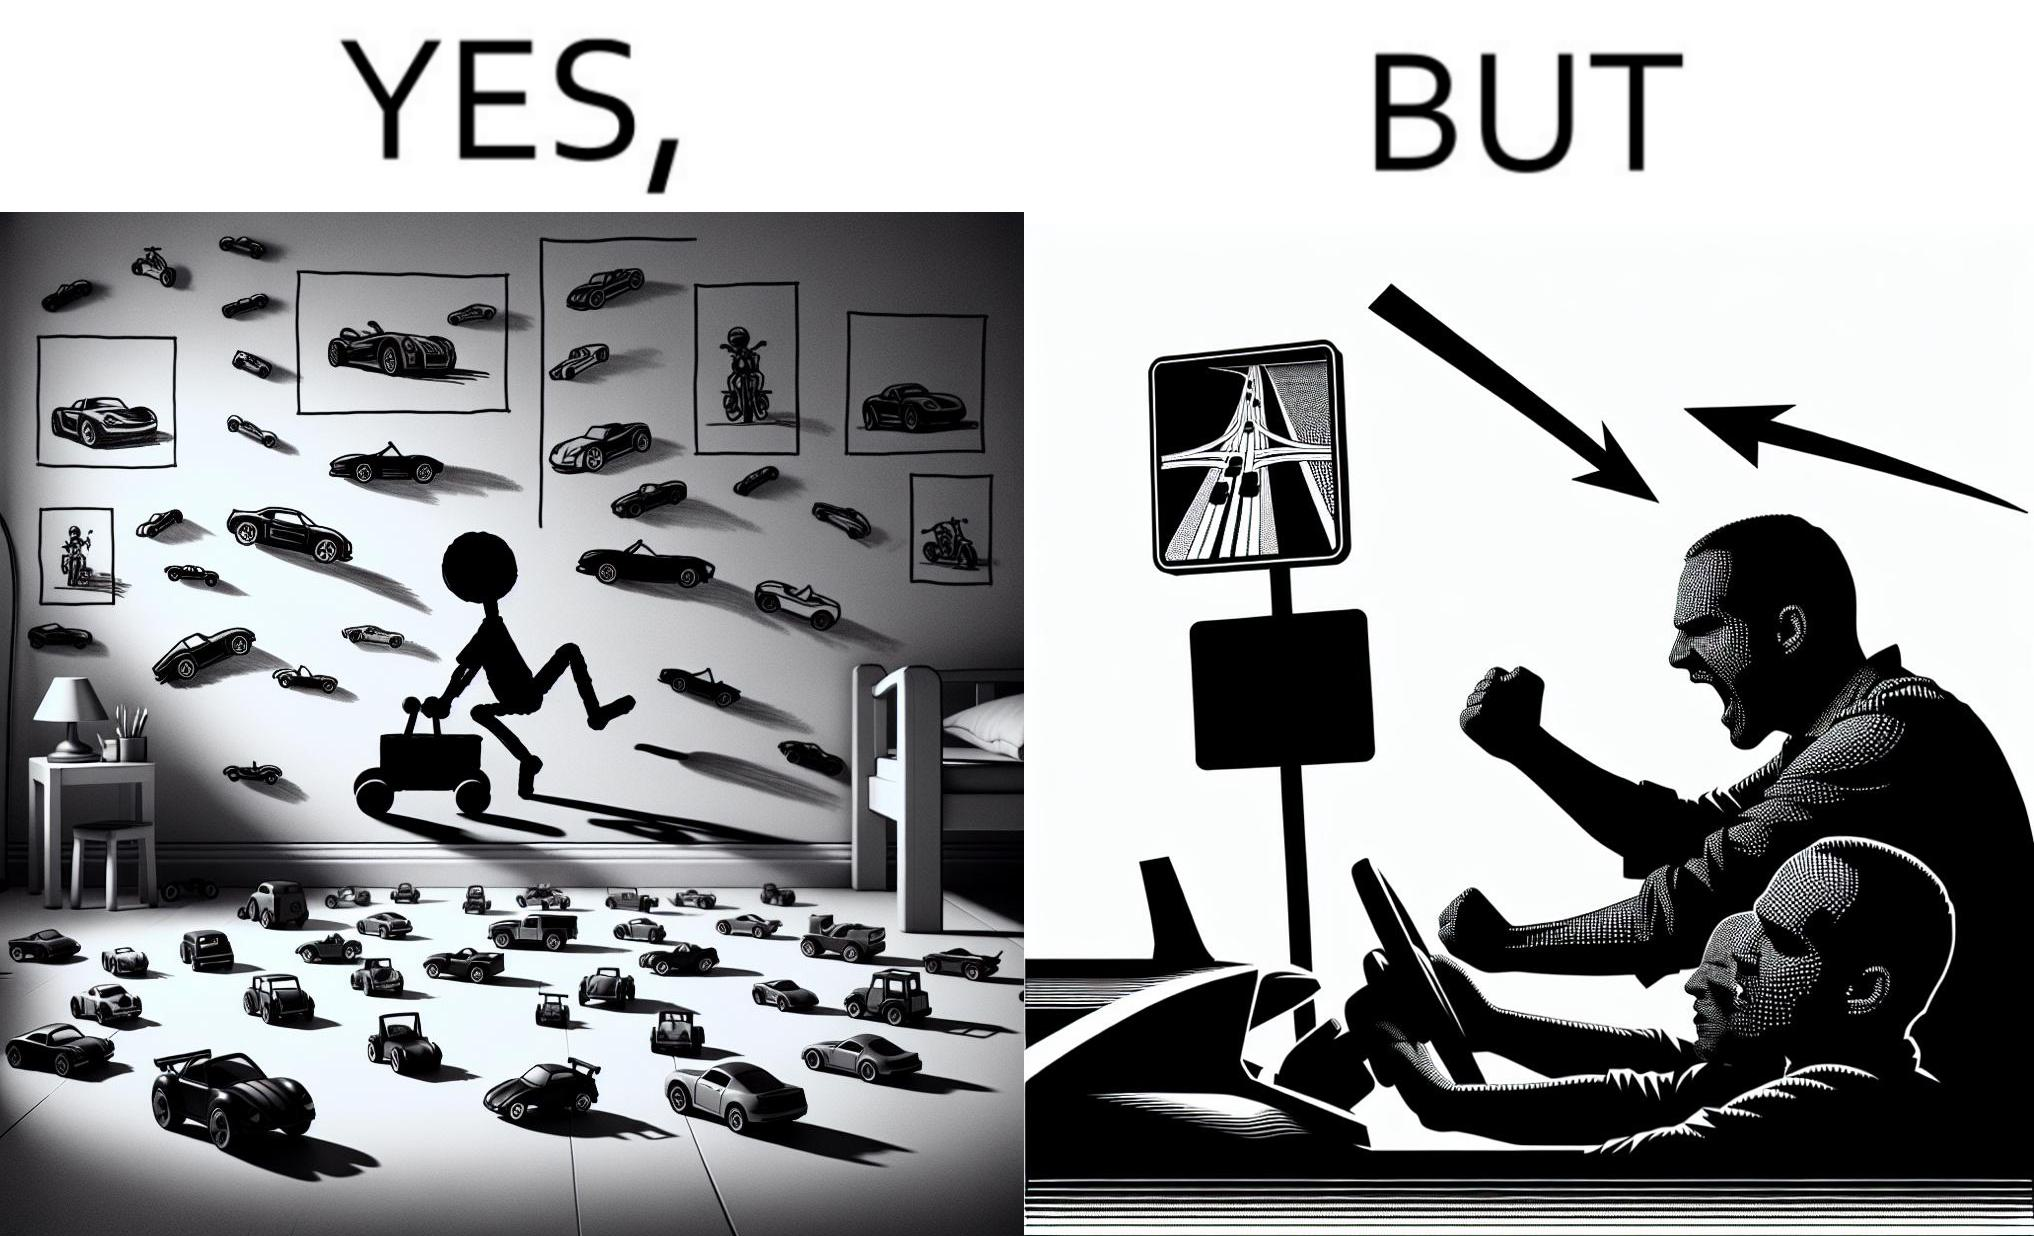Describe the contrast between the left and right parts of this image. In the left part of the image: The image shows the bedroom of a child with various small toy cars and posters of cars on the wall. The child in the picture is also riding a bigger toy car. In the right part of the image: The image shows a man annoyed by the slow traffic on his way as shown on the map while he is driving. 